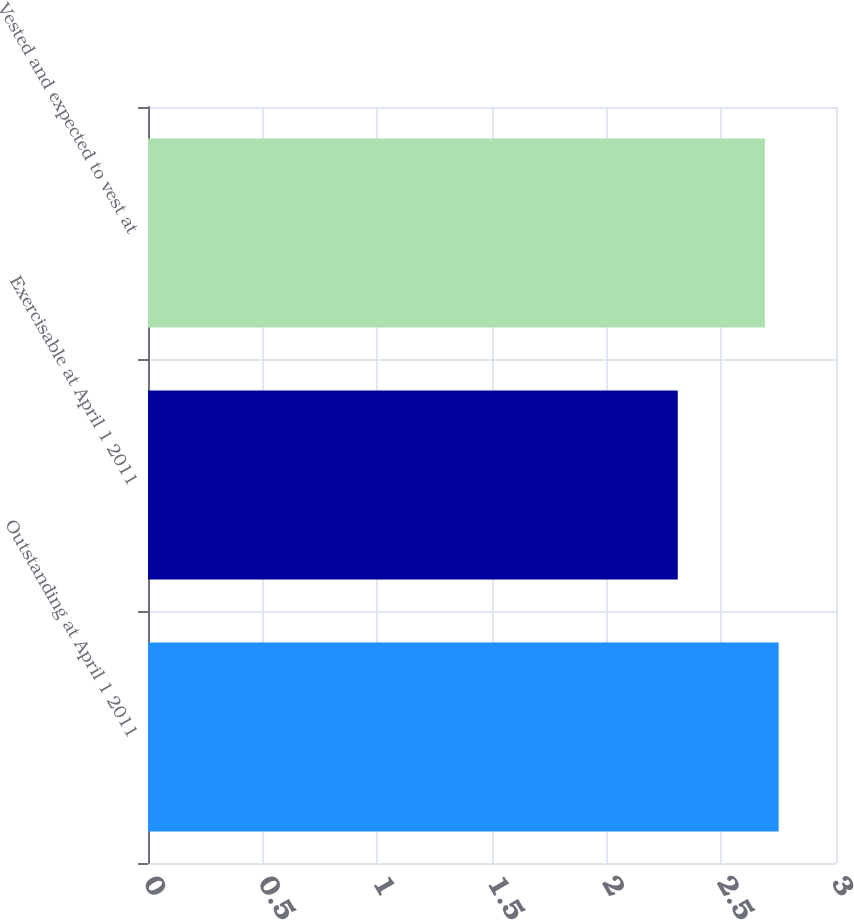Convert chart to OTSL. <chart><loc_0><loc_0><loc_500><loc_500><bar_chart><fcel>Outstanding at April 1 2011<fcel>Exercisable at April 1 2011<fcel>Vested and expected to vest at<nl><fcel>2.75<fcel>2.31<fcel>2.69<nl></chart> 